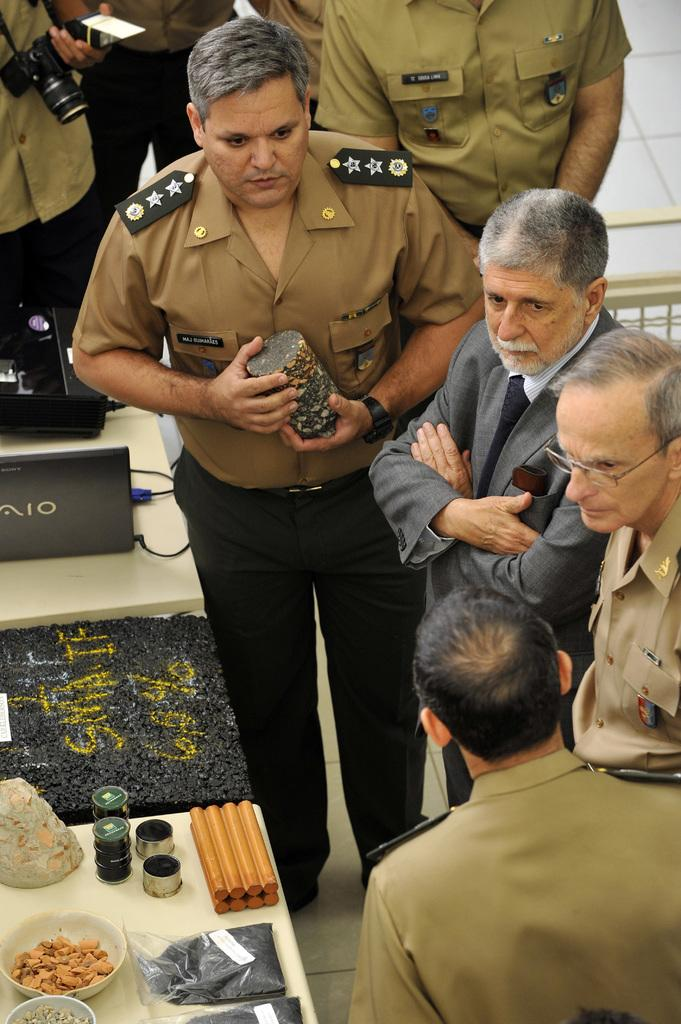What can be seen in the image? There are people standing in the image. Where are the people standing? The people are standing on the floor. What is in front of the people? There are tables in front of the people. What is on top of the tables? There are laptops and other objects on top of the tables. What year is depicted in the image? The provided facts do not mention any specific year, so it cannot be determined from the image. 